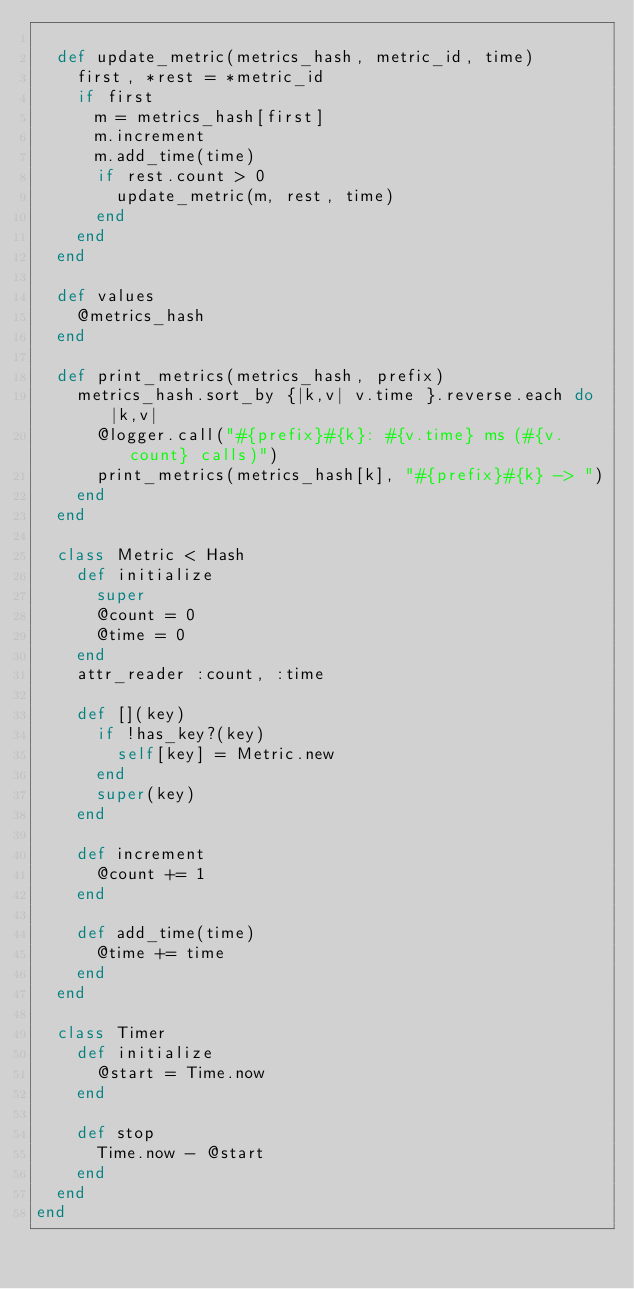Convert code to text. <code><loc_0><loc_0><loc_500><loc_500><_Ruby_>
  def update_metric(metrics_hash, metric_id, time)
    first, *rest = *metric_id
    if first
      m = metrics_hash[first]
      m.increment
      m.add_time(time)
      if rest.count > 0
        update_metric(m, rest, time)
      end
    end
  end

  def values
    @metrics_hash
  end

  def print_metrics(metrics_hash, prefix)
    metrics_hash.sort_by {|k,v| v.time }.reverse.each do |k,v|
      @logger.call("#{prefix}#{k}: #{v.time} ms (#{v.count} calls)")
      print_metrics(metrics_hash[k], "#{prefix}#{k} -> ")
    end
  end

  class Metric < Hash
    def initialize
      super
      @count = 0
      @time = 0
    end
    attr_reader :count, :time

    def [](key)
      if !has_key?(key)
        self[key] = Metric.new
      end
      super(key)
    end

    def increment
      @count += 1
    end

    def add_time(time)
      @time += time
    end
  end

  class Timer
    def initialize
      @start = Time.now
    end

    def stop
      Time.now - @start
    end
  end
end

</code> 